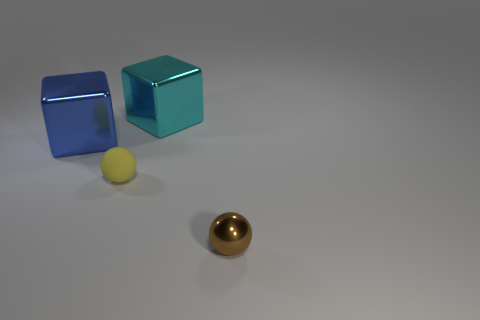Add 1 metal balls. How many objects exist? 5 Subtract all cyan cubes. How many cubes are left? 1 Subtract 2 spheres. How many spheres are left? 0 Subtract all green blocks. Subtract all brown cylinders. How many blocks are left? 2 Subtract all gray blocks. How many blue balls are left? 0 Subtract all small rubber spheres. Subtract all big things. How many objects are left? 1 Add 3 brown things. How many brown things are left? 4 Add 2 brown things. How many brown things exist? 3 Subtract 0 blue spheres. How many objects are left? 4 